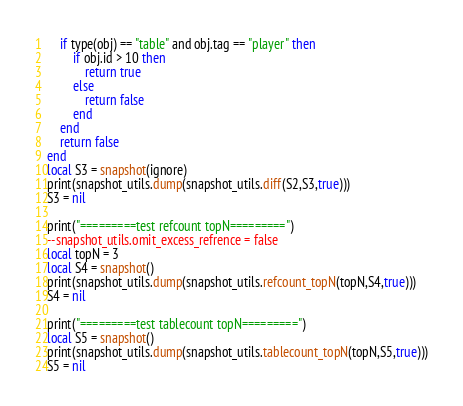Convert code to text. <code><loc_0><loc_0><loc_500><loc_500><_Lua_>    if type(obj) == "table" and obj.tag == "player" then
        if obj.id > 10 then
            return true
        else
            return false
        end
    end
    return false
end
local S3 = snapshot(ignore)
print(snapshot_utils.dump(snapshot_utils.diff(S2,S3,true)))
S3 = nil

print("=========test refcount topN=========")
--snapshot_utils.omit_excess_refrence = false
local topN = 3
local S4 = snapshot()
print(snapshot_utils.dump(snapshot_utils.refcount_topN(topN,S4,true)))
S4 = nil

print("=========test tablecount topN=========")
local S5 = snapshot()
print(snapshot_utils.dump(snapshot_utils.tablecount_topN(topN,S5,true)))
S5 = nil</code> 